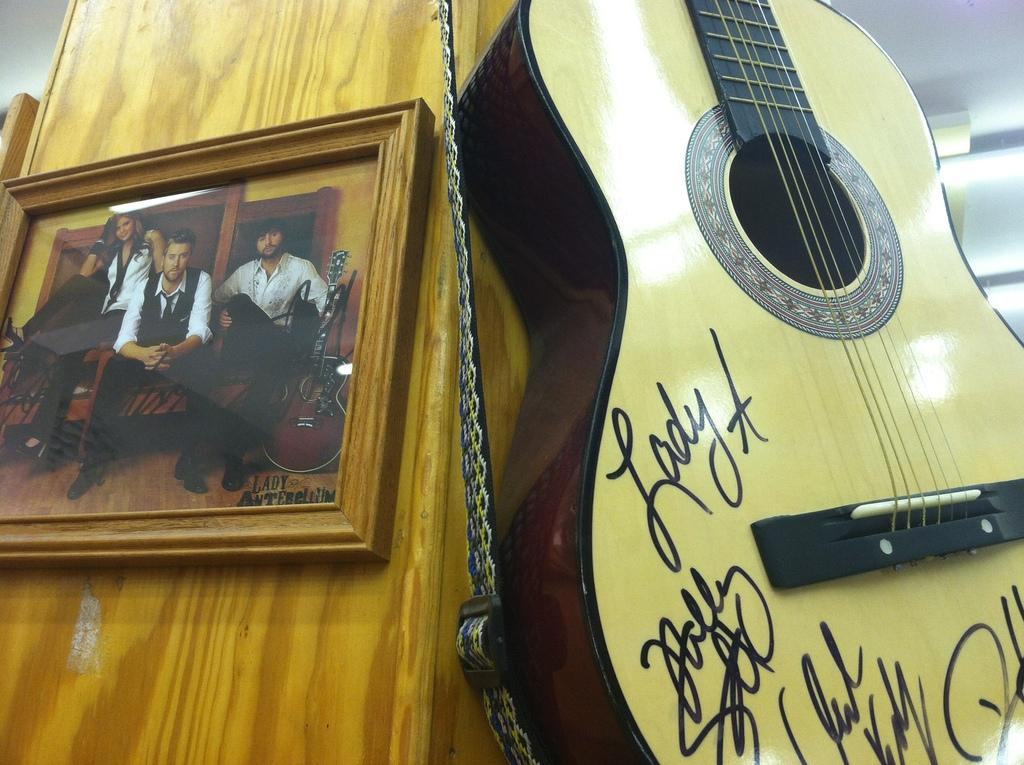What musical instrument is present in the image? There is a guitar in the image. What other object can be seen in the image? There is a frame in the image. Where are the guitar and frame located? Both the guitar and frame are on a wooden wall. What type of copper vein can be seen running through the guitar in the image? There is no copper vein present in the image, and the guitar is not made of copper. 